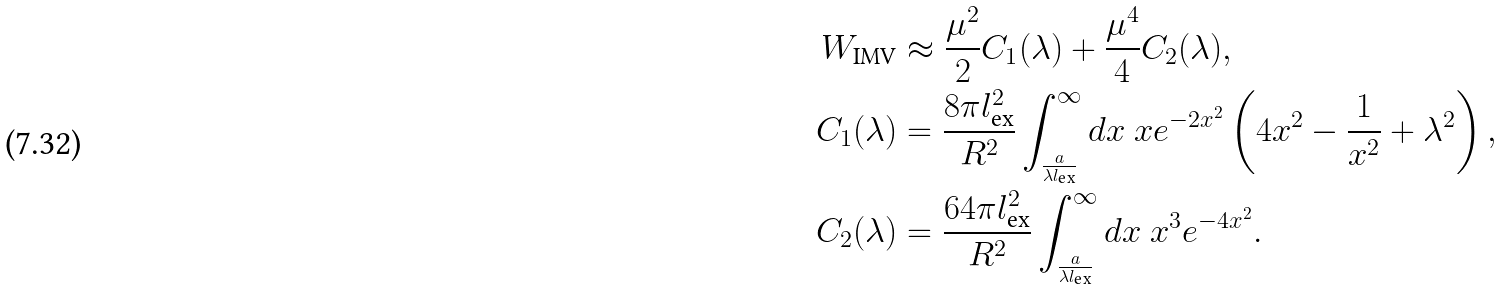<formula> <loc_0><loc_0><loc_500><loc_500>W _ { \text {IMV} } & \approx \frac { \mu ^ { 2 } } { 2 } C _ { 1 } ( \lambda ) + \frac { \mu ^ { 4 } } { 4 } C _ { 2 } ( \lambda ) , \\ C _ { 1 } ( \lambda ) & = \frac { 8 \pi l _ { \text {ex} } ^ { 2 } } { R ^ { 2 } } \int _ { \frac { a } { \lambda l _ { \text {ex} } } } ^ { \infty } d x \ x e ^ { - 2 x ^ { 2 } } \left ( 4 x ^ { 2 } - \frac { 1 } { x ^ { 2 } } + \lambda ^ { 2 } \right ) , \\ C _ { 2 } ( \lambda ) & = \frac { 6 4 \pi l _ { \text {ex} } ^ { 2 } } { R ^ { 2 } } \int _ { \frac { a } { \lambda l _ { \text {ex} } } } ^ { \infty } d x \ x ^ { 3 } e ^ { - 4 x ^ { 2 } } .</formula> 